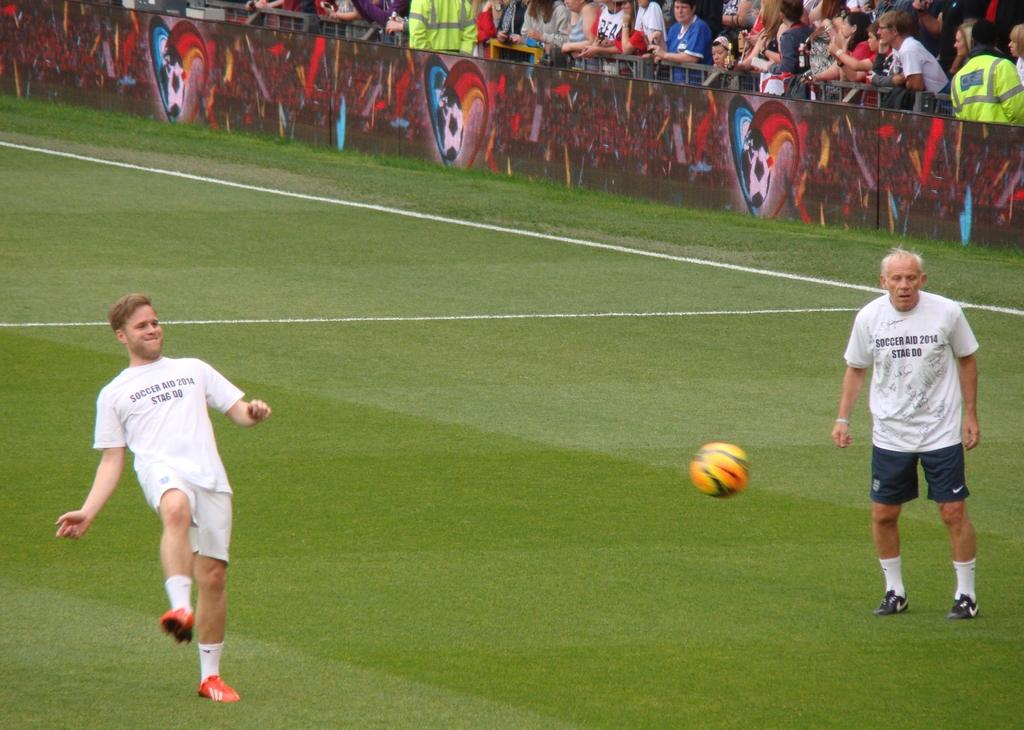<image>
Relay a brief, clear account of the picture shown. Soccer player on the field wearing a white shirt that says Soccer Aid 2014. 